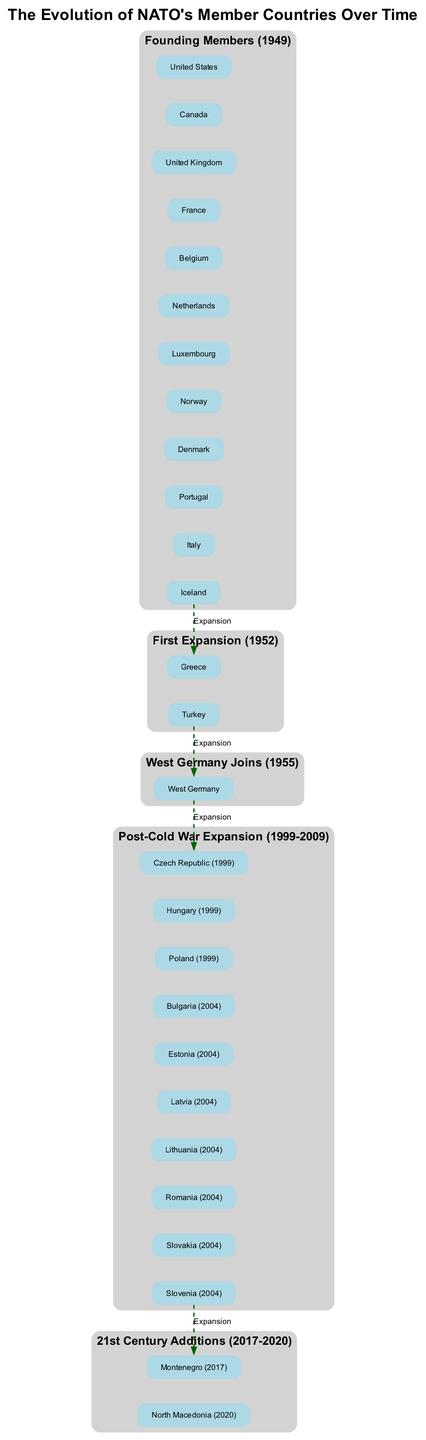What year were NATO's founding members established? The founding members of NATO were established in 1949. This can be determined by looking at the block labeled "Founding Members (1949)" in the diagram, which directly presents the year beside the label.
Answer: 1949 How many countries joined NATO during the first expansion? The first expansion of NATO, which took place in 1952, included two countries: Greece and Turkey. This is clear from the block labeled "First Expansion (1952)", which lists these two countries.
Answer: 2 Which country joined NATO in 1955? The diagram shows that West Germany joined NATO in 1955, as indicated by the block labeled "West Germany Joins (1955)", which solely lists West Germany.
Answer: West Germany What is the total number of countries represented in the post-Cold War expansion? In the post-Cold War expansion (1999-2009), there are ten countries: Czech Republic, Hungary, Poland, Bulgaria, Estonia, Latvia, Lithuania, Romania, Slovakia, and Slovenia. The block labeled "Post-Cold War Expansion (1999-2009)" lists all these countries, allowing for a simple count of ten.
Answer: 10 Which two countries were NATO's latest members before 2021? The latest additions to NATO before 2021 were Montenegro in 2017 and North Macedonia in 2020. Referring to the block labeled "21st Century Additions (2017-2020)" reveals these two countries.
Answer: Montenegro, North Macedonia What type of relationship is indicated between the blocks in the diagram? The relationship between the blocks indicates expansions of NATO membership over time, signified by a dashed line labeled "Expansion". This connection can be traced as it connects each successive block logically, reflecting the sequence of membership increases.
Answer: Expansion How many founding members were there in total? The block labeled "Founding Members (1949)" contains a total of twelve countries, which can be verified by counting each country listed within that block.
Answer: 12 What is the significance of the block labeled "Post-Cold War Expansion (1999-2009)"? This block signifies a significant increase in NATO membership as it denotes ten new countries that joined after the Cold War, representing a shift in NATO's role and capabilities in the post-Cold War context. Its importance is underlined by the number of countries it represents compared to other expansions.
Answer: Significant increase in membership 